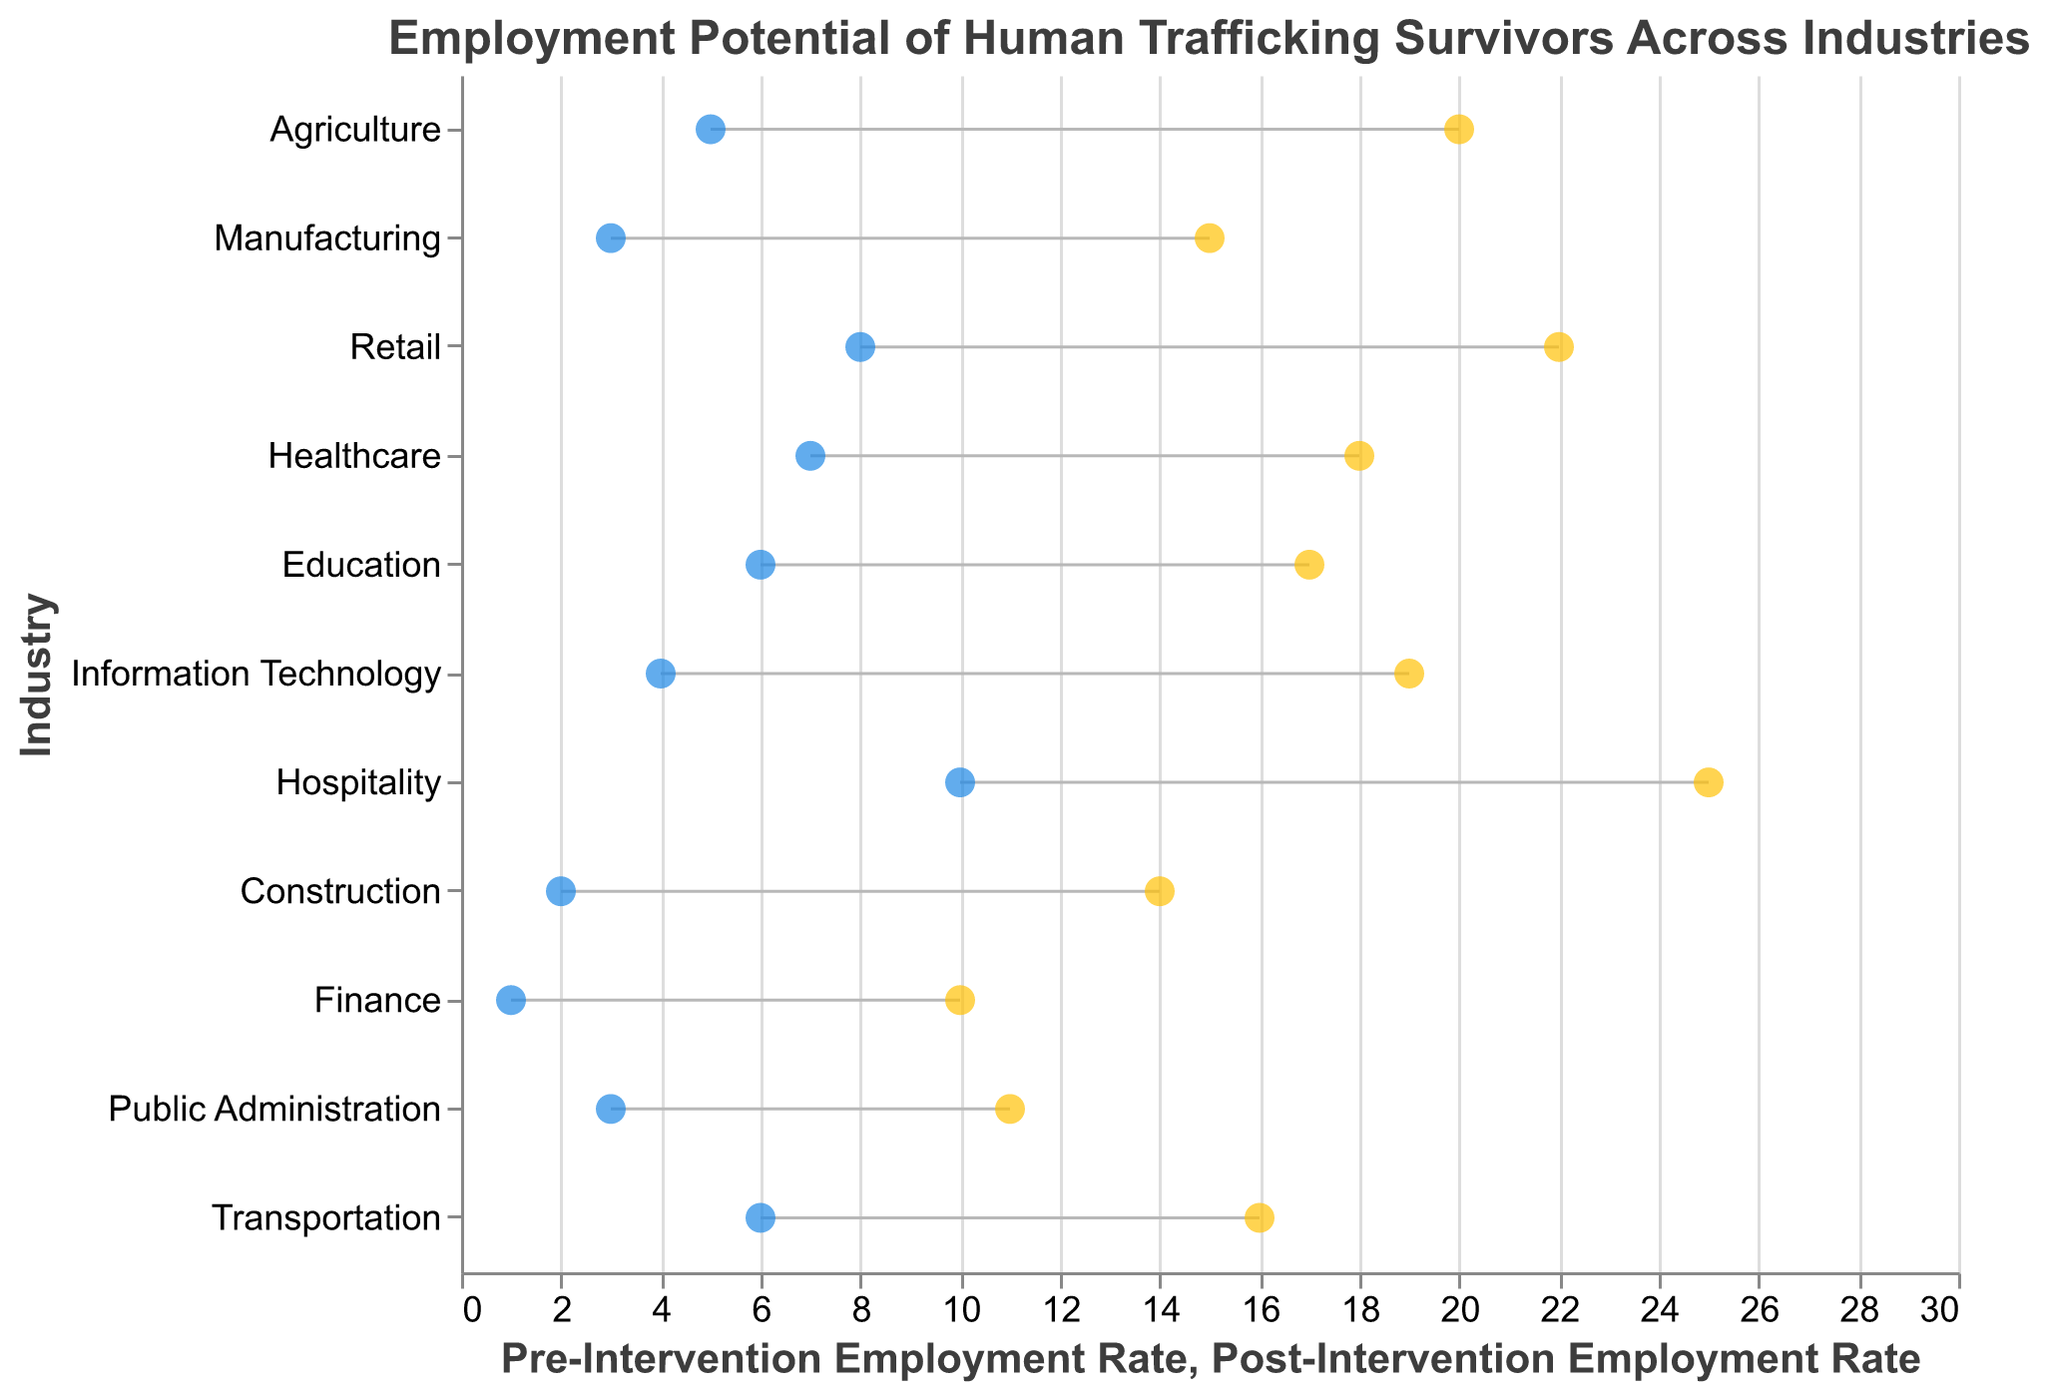How many industries have a post-intervention employment rate greater than 20%? There are 11 industries in total. Checking each industry's post-intervention employment rate: Agriculture (20), Manufacturing (15), Retail (22), Healthcare (18), Education (17), Information Technology (19), Hospitality (25), Construction (14), Finance (10), Public Administration (11), Transportation (16). Retail and Hospitality have post-intervention employment rates greater than 20%.
Answer: 2 Which industry shows the largest increase in employment rate after the intervention? To find the industry with the largest increase, calculate the difference between post-intervention and pre-intervention rates for each industry: Agriculture (15), Manufacturing (12), Retail (14), Healthcare (11), Education (11), Information Technology (15), Hospitality (15), Construction (12), Finance (9), Public Administration (8), Transportation (10). Agriculture, IT, and Hospitality all show an increase of 15.
Answer: Agriculture, Information Technology, Hospitality What is the difference in post-intervention employment rates between Retail and Education? Find the post-intervention employment rates for Retail (22) and Education (17), then subtract the rate of Education from the rate of Retail: 22 - 17 = 5.
Answer: 5 What are the pre- and post-intervention employment rates for the Retail industry? From the data, the pre-intervention rate for Retail is 8, and the post-intervention rate is 22.
Answer: Pre: 8, Post: 22 Which industry has the lowest pre-intervention employment rate, and what is that rate? By looking at the pre-intervention employment rates: Agriculture (5), Manufacturing (3), Retail (8), Healthcare (7), Education (6), Information Technology (4), Hospitality (10), Construction (2), Finance (1), Public Administration (3), Transportation (6), Finance has the lowest rate at 1.
Answer: Finance with a rate of 1 Identify the industry with the highest post-intervention employment rate. By checking the post-intervention employment rates: Agriculture (20), Manufacturing (15), Retail (22), Healthcare (18), Education (17), Information Technology (19), Hospitality (25), Construction (14), Finance (10), Public Administration (11), Transportation (16), Hospitality has the highest rate at 25.
Answer: Hospitality Calculate the average pre-intervention employment rate across all industries. Sum the pre-intervention employment rates: 5 (Agriculture) + 3 (Manufacturing) + 8 (Retail) + 7 (Healthcare) + 6 (Education) + 4 (Information Technology) + 10 (Hospitality) + 2 (Construction) + 1 (Finance) + 3 (Public Administration) + 6 (Transportation) = 55. Divide by the number of industries: 55 / 11 = 5.
Answer: 5 Compare the change in employment rates between Construction and Finance. Which industry shows a higher increase? Calculate the change for Construction: Post (14) - Pre (2) = 12, and for Finance: Post (10) - Pre (1) = 9. Construction shows a higher increase of 12 vs. Finance's 9.
Answer: Construction Which industry falls directly in the middle when industries are sorted by post-intervention employment rates? When sorting industries by post-intervention rates: Hospitality (25), Retail (22), Agriculture (20), Information Technology (19), Healthcare (18), Education (17), Transportation (16), Manufacturing (15), Construction (14), Public Administration (11), Finance (10), Education is in the middle with a rate of 17.
Answer: Education 